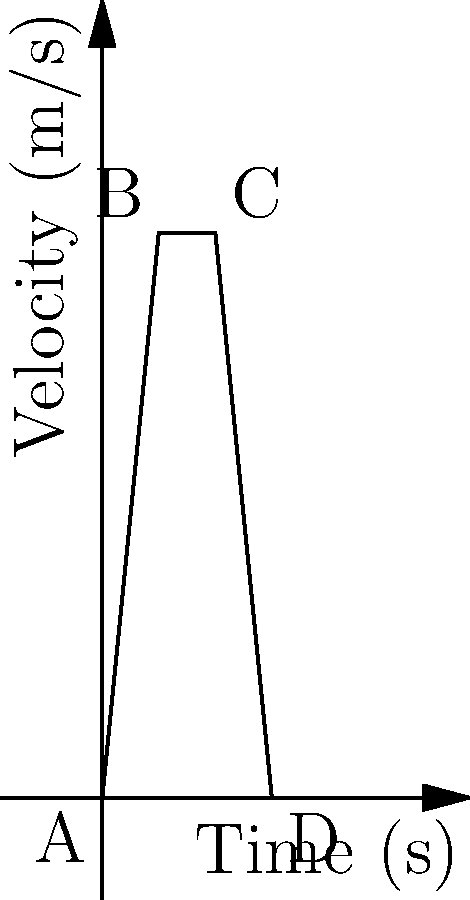A wide receiver runs a route as shown in the velocity-time graph above. Calculate the receiver's average acceleration from point A to B and average deceleration from point C to D. To solve this problem, we'll use the formula for average acceleration: $a = \frac{\Delta v}{\Delta t}$

1. Acceleration from A to B:
   - Initial velocity (v₀) at A: 0 m/s
   - Final velocity (v) at B: 20 m/s
   - Time interval: 2 s
   
   $a_{AB} = \frac{v - v_0}{t} = \frac{20 - 0}{2} = 10$ m/s²

2. Deceleration from C to D:
   - Initial velocity (v₀) at C: 20 m/s
   - Final velocity (v) at D: 0 m/s
   - Time interval: 2 s
   
   $a_{CD} = \frac{v - v_0}{t} = \frac{0 - 20}{2} = -10$ m/s²

The negative sign indicates deceleration.
Answer: Acceleration A to B: 10 m/s², Deceleration C to D: 10 m/s² 